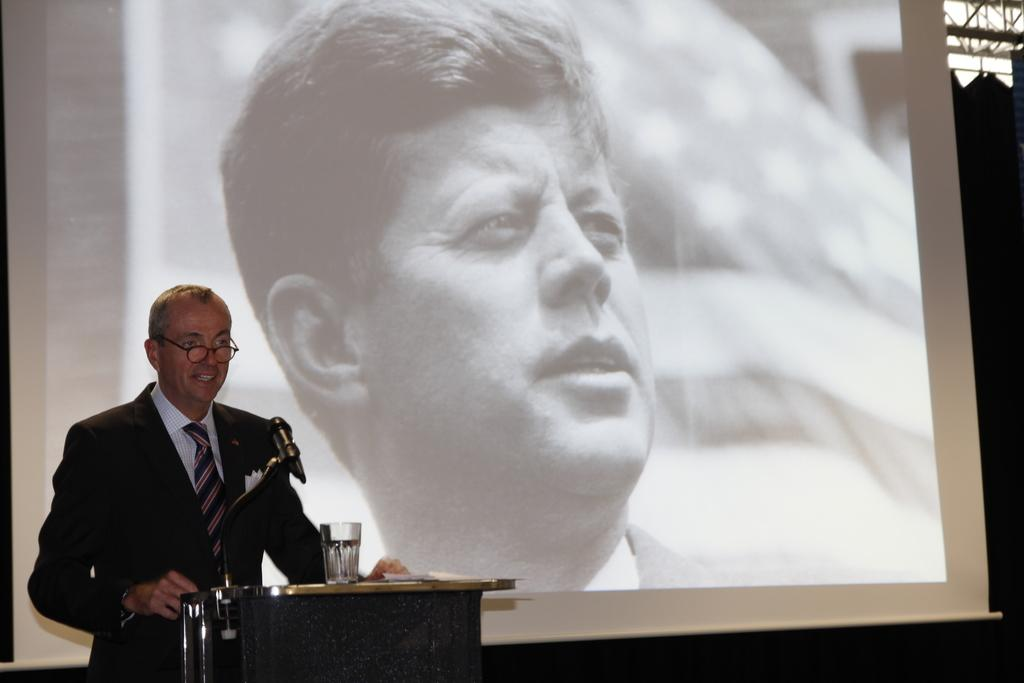What is the man in the image doing? The man is standing and talking. What object is present in the image that is typically used for public speaking? There is a podium in the image. What is on the podium? The podium has a microphone, a tumbler, and papers on it. What can be seen on the screen in the image? There is a screen displaying a person in the image. What type of ray is visible on the table in the image? There is no ray visible on a table in the image; the image does not show any tables. 